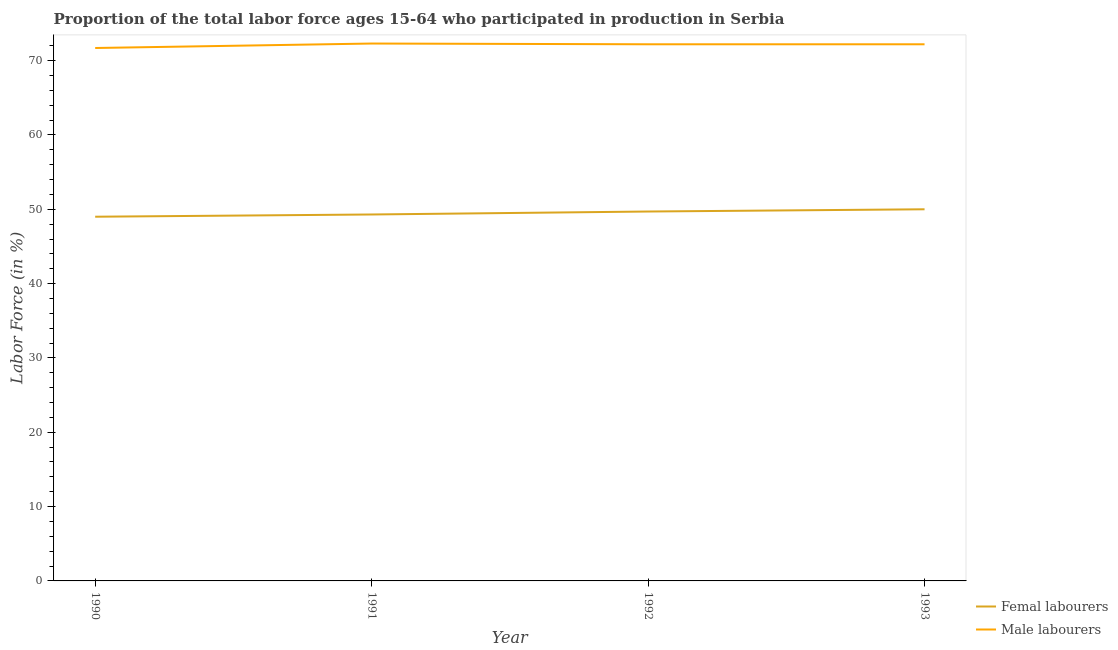How many different coloured lines are there?
Ensure brevity in your answer.  2. What is the percentage of female labor force in 1992?
Provide a short and direct response. 49.7. Across all years, what is the maximum percentage of male labour force?
Your answer should be compact. 72.3. Across all years, what is the minimum percentage of female labor force?
Make the answer very short. 49. In which year was the percentage of male labour force maximum?
Your answer should be compact. 1991. What is the total percentage of male labour force in the graph?
Provide a short and direct response. 288.4. What is the difference between the percentage of male labour force in 1990 and that in 1992?
Keep it short and to the point. -0.5. What is the difference between the percentage of male labour force in 1992 and the percentage of female labor force in 1990?
Give a very brief answer. 23.2. What is the average percentage of female labor force per year?
Keep it short and to the point. 49.5. In the year 1990, what is the difference between the percentage of male labour force and percentage of female labor force?
Provide a short and direct response. 22.7. What is the ratio of the percentage of male labour force in 1991 to that in 1993?
Provide a short and direct response. 1. Is the percentage of male labour force in 1991 less than that in 1993?
Make the answer very short. No. Is the difference between the percentage of female labor force in 1990 and 1992 greater than the difference between the percentage of male labour force in 1990 and 1992?
Offer a terse response. No. What is the difference between the highest and the second highest percentage of male labour force?
Keep it short and to the point. 0.1. What is the difference between the highest and the lowest percentage of female labor force?
Your response must be concise. 1. In how many years, is the percentage of female labor force greater than the average percentage of female labor force taken over all years?
Provide a succinct answer. 2. How many lines are there?
Give a very brief answer. 2. How many years are there in the graph?
Offer a terse response. 4. What is the difference between two consecutive major ticks on the Y-axis?
Offer a terse response. 10. Are the values on the major ticks of Y-axis written in scientific E-notation?
Your answer should be very brief. No. Does the graph contain any zero values?
Offer a terse response. No. How are the legend labels stacked?
Offer a terse response. Vertical. What is the title of the graph?
Your response must be concise. Proportion of the total labor force ages 15-64 who participated in production in Serbia. What is the label or title of the Y-axis?
Provide a succinct answer. Labor Force (in %). What is the Labor Force (in %) of Male labourers in 1990?
Your answer should be very brief. 71.7. What is the Labor Force (in %) in Femal labourers in 1991?
Your answer should be compact. 49.3. What is the Labor Force (in %) in Male labourers in 1991?
Keep it short and to the point. 72.3. What is the Labor Force (in %) of Femal labourers in 1992?
Provide a short and direct response. 49.7. What is the Labor Force (in %) in Male labourers in 1992?
Keep it short and to the point. 72.2. What is the Labor Force (in %) in Femal labourers in 1993?
Give a very brief answer. 50. What is the Labor Force (in %) of Male labourers in 1993?
Provide a succinct answer. 72.2. Across all years, what is the maximum Labor Force (in %) of Femal labourers?
Provide a succinct answer. 50. Across all years, what is the maximum Labor Force (in %) of Male labourers?
Keep it short and to the point. 72.3. Across all years, what is the minimum Labor Force (in %) in Male labourers?
Offer a terse response. 71.7. What is the total Labor Force (in %) in Femal labourers in the graph?
Make the answer very short. 198. What is the total Labor Force (in %) of Male labourers in the graph?
Your answer should be compact. 288.4. What is the difference between the Labor Force (in %) in Femal labourers in 1990 and that in 1992?
Offer a very short reply. -0.7. What is the difference between the Labor Force (in %) of Male labourers in 1990 and that in 1992?
Ensure brevity in your answer.  -0.5. What is the difference between the Labor Force (in %) in Femal labourers in 1990 and that in 1993?
Provide a succinct answer. -1. What is the difference between the Labor Force (in %) in Male labourers in 1990 and that in 1993?
Offer a terse response. -0.5. What is the difference between the Labor Force (in %) of Femal labourers in 1991 and that in 1993?
Make the answer very short. -0.7. What is the difference between the Labor Force (in %) of Male labourers in 1992 and that in 1993?
Ensure brevity in your answer.  0. What is the difference between the Labor Force (in %) in Femal labourers in 1990 and the Labor Force (in %) in Male labourers in 1991?
Offer a very short reply. -23.3. What is the difference between the Labor Force (in %) of Femal labourers in 1990 and the Labor Force (in %) of Male labourers in 1992?
Your answer should be very brief. -23.2. What is the difference between the Labor Force (in %) of Femal labourers in 1990 and the Labor Force (in %) of Male labourers in 1993?
Your response must be concise. -23.2. What is the difference between the Labor Force (in %) in Femal labourers in 1991 and the Labor Force (in %) in Male labourers in 1992?
Keep it short and to the point. -22.9. What is the difference between the Labor Force (in %) of Femal labourers in 1991 and the Labor Force (in %) of Male labourers in 1993?
Your answer should be compact. -22.9. What is the difference between the Labor Force (in %) of Femal labourers in 1992 and the Labor Force (in %) of Male labourers in 1993?
Your answer should be very brief. -22.5. What is the average Labor Force (in %) of Femal labourers per year?
Your answer should be very brief. 49.5. What is the average Labor Force (in %) of Male labourers per year?
Your answer should be compact. 72.1. In the year 1990, what is the difference between the Labor Force (in %) in Femal labourers and Labor Force (in %) in Male labourers?
Keep it short and to the point. -22.7. In the year 1992, what is the difference between the Labor Force (in %) of Femal labourers and Labor Force (in %) of Male labourers?
Your response must be concise. -22.5. In the year 1993, what is the difference between the Labor Force (in %) in Femal labourers and Labor Force (in %) in Male labourers?
Make the answer very short. -22.2. What is the ratio of the Labor Force (in %) of Male labourers in 1990 to that in 1991?
Provide a short and direct response. 0.99. What is the ratio of the Labor Force (in %) in Femal labourers in 1990 to that in 1992?
Offer a terse response. 0.99. What is the ratio of the Labor Force (in %) of Male labourers in 1990 to that in 1992?
Ensure brevity in your answer.  0.99. What is the ratio of the Labor Force (in %) of Femal labourers in 1990 to that in 1993?
Your response must be concise. 0.98. What is the ratio of the Labor Force (in %) of Male labourers in 1990 to that in 1993?
Offer a terse response. 0.99. What is the ratio of the Labor Force (in %) in Femal labourers in 1991 to that in 1992?
Provide a short and direct response. 0.99. What is the ratio of the Labor Force (in %) of Male labourers in 1991 to that in 1992?
Provide a short and direct response. 1. What is the ratio of the Labor Force (in %) in Femal labourers in 1991 to that in 1993?
Your answer should be compact. 0.99. What is the difference between the highest and the second highest Labor Force (in %) in Femal labourers?
Your answer should be compact. 0.3. What is the difference between the highest and the second highest Labor Force (in %) in Male labourers?
Offer a terse response. 0.1. What is the difference between the highest and the lowest Labor Force (in %) of Femal labourers?
Your answer should be compact. 1. What is the difference between the highest and the lowest Labor Force (in %) in Male labourers?
Your answer should be very brief. 0.6. 